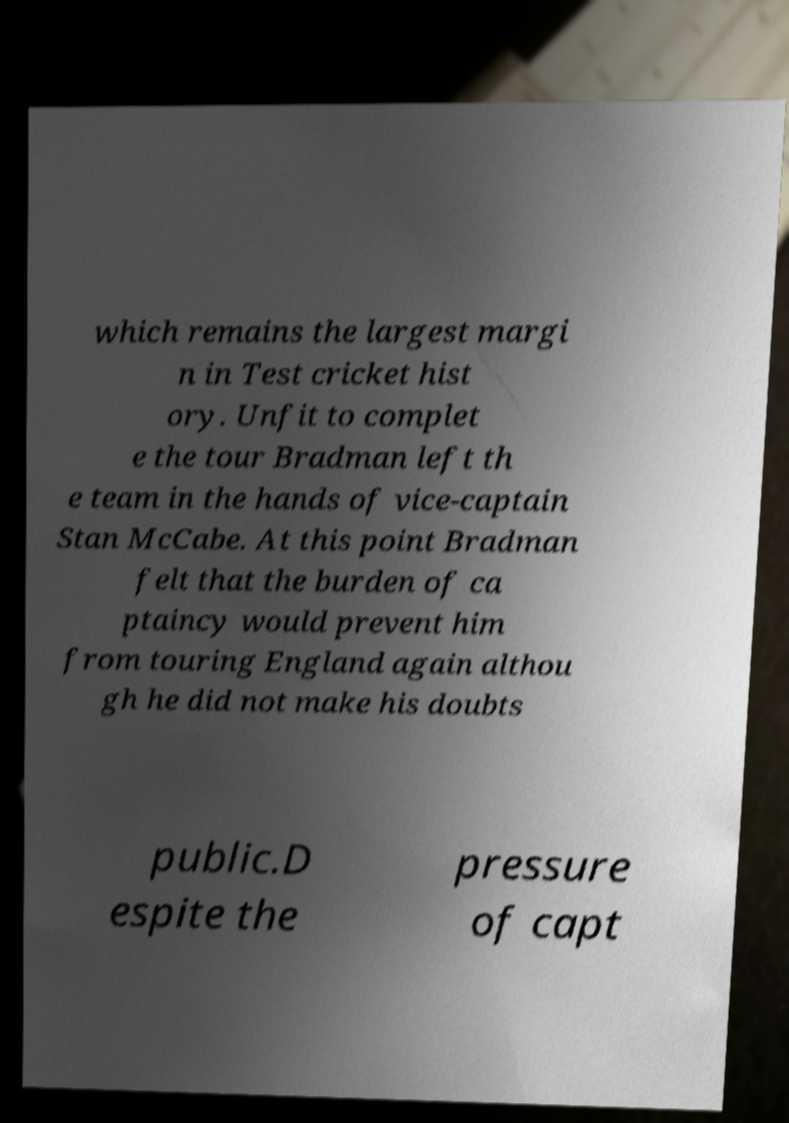I need the written content from this picture converted into text. Can you do that? which remains the largest margi n in Test cricket hist ory. Unfit to complet e the tour Bradman left th e team in the hands of vice-captain Stan McCabe. At this point Bradman felt that the burden of ca ptaincy would prevent him from touring England again althou gh he did not make his doubts public.D espite the pressure of capt 